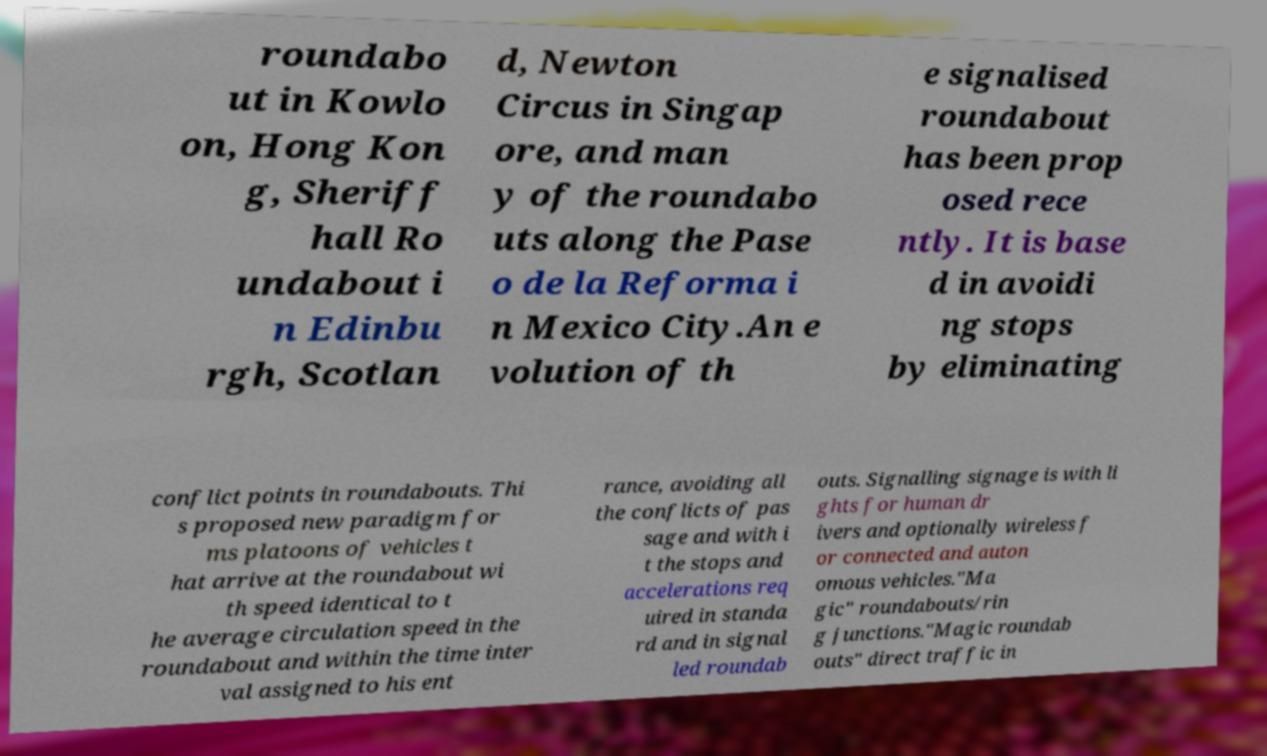Please read and relay the text visible in this image. What does it say? roundabo ut in Kowlo on, Hong Kon g, Sheriff hall Ro undabout i n Edinbu rgh, Scotlan d, Newton Circus in Singap ore, and man y of the roundabo uts along the Pase o de la Reforma i n Mexico City.An e volution of th e signalised roundabout has been prop osed rece ntly. It is base d in avoidi ng stops by eliminating conflict points in roundabouts. Thi s proposed new paradigm for ms platoons of vehicles t hat arrive at the roundabout wi th speed identical to t he average circulation speed in the roundabout and within the time inter val assigned to his ent rance, avoiding all the conflicts of pas sage and with i t the stops and accelerations req uired in standa rd and in signal led roundab outs. Signalling signage is with li ghts for human dr ivers and optionally wireless f or connected and auton omous vehicles."Ma gic" roundabouts/rin g junctions."Magic roundab outs" direct traffic in 